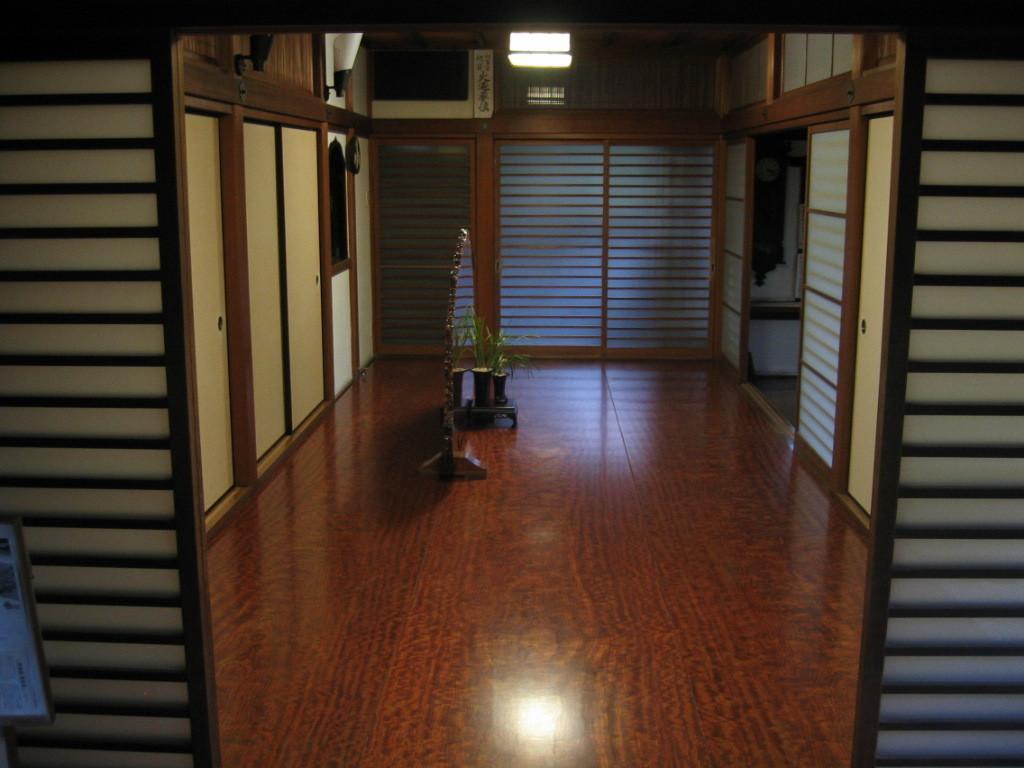Describe this image in one or two sentences. This is the interior of the house, there is a house plant in the image, there is a lamp which is glowing. 